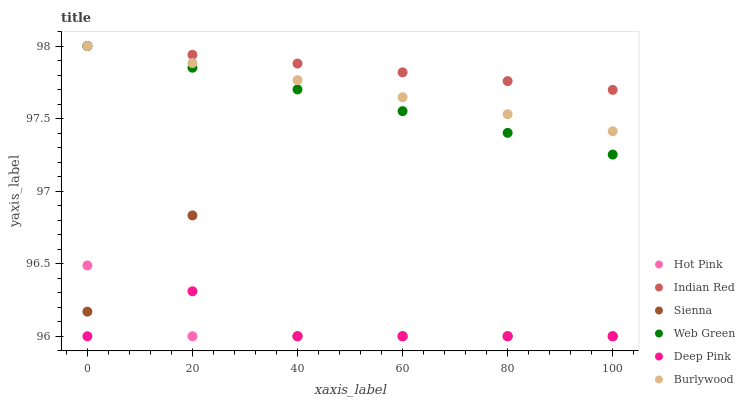Does Hot Pink have the minimum area under the curve?
Answer yes or no. Yes. Does Indian Red have the maximum area under the curve?
Answer yes or no. Yes. Does Burlywood have the minimum area under the curve?
Answer yes or no. No. Does Burlywood have the maximum area under the curve?
Answer yes or no. No. Is Burlywood the smoothest?
Answer yes or no. Yes. Is Sienna the roughest?
Answer yes or no. Yes. Is Hot Pink the smoothest?
Answer yes or no. No. Is Hot Pink the roughest?
Answer yes or no. No. Does Deep Pink have the lowest value?
Answer yes or no. Yes. Does Burlywood have the lowest value?
Answer yes or no. No. Does Indian Red have the highest value?
Answer yes or no. Yes. Does Hot Pink have the highest value?
Answer yes or no. No. Is Sienna less than Web Green?
Answer yes or no. Yes. Is Indian Red greater than Deep Pink?
Answer yes or no. Yes. Does Sienna intersect Hot Pink?
Answer yes or no. Yes. Is Sienna less than Hot Pink?
Answer yes or no. No. Is Sienna greater than Hot Pink?
Answer yes or no. No. Does Sienna intersect Web Green?
Answer yes or no. No. 